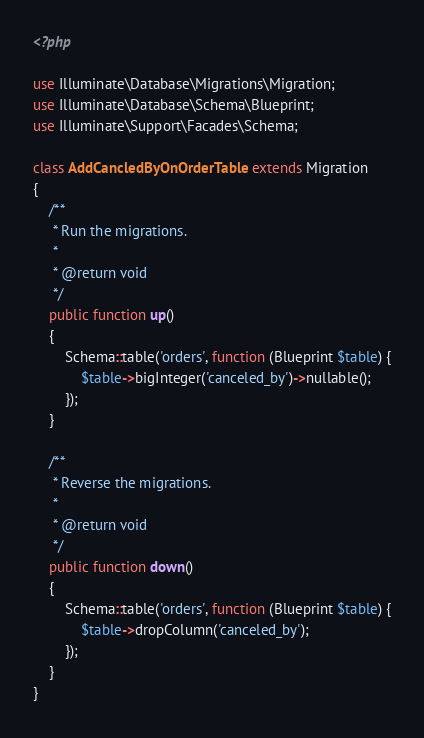<code> <loc_0><loc_0><loc_500><loc_500><_PHP_><?php

use Illuminate\Database\Migrations\Migration;
use Illuminate\Database\Schema\Blueprint;
use Illuminate\Support\Facades\Schema;

class AddCancledByOnOrderTable extends Migration
{
    /**
     * Run the migrations.
     *
     * @return void
     */
    public function up()
    {
        Schema::table('orders', function (Blueprint $table) {
            $table->bigInteger('canceled_by')->nullable();
        });
    }

    /**
     * Reverse the migrations.
     *
     * @return void
     */
    public function down()
    {
        Schema::table('orders', function (Blueprint $table) {
            $table->dropColumn('canceled_by');
        });
    }
}
</code> 